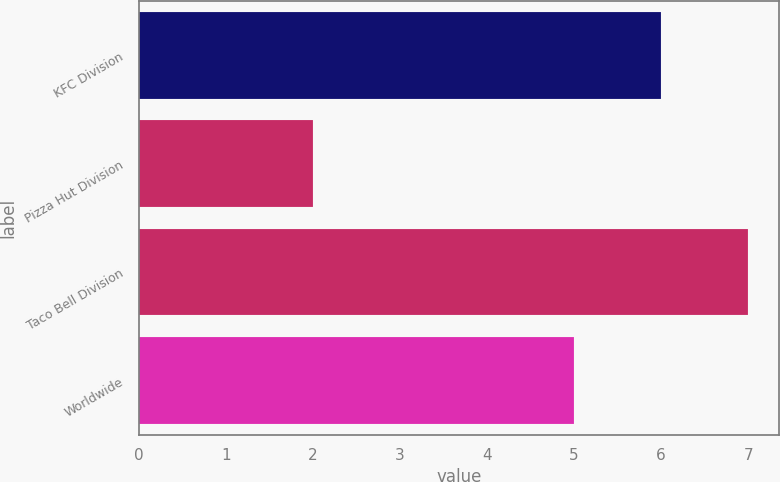Convert chart. <chart><loc_0><loc_0><loc_500><loc_500><bar_chart><fcel>KFC Division<fcel>Pizza Hut Division<fcel>Taco Bell Division<fcel>Worldwide<nl><fcel>6<fcel>2<fcel>7<fcel>5<nl></chart> 